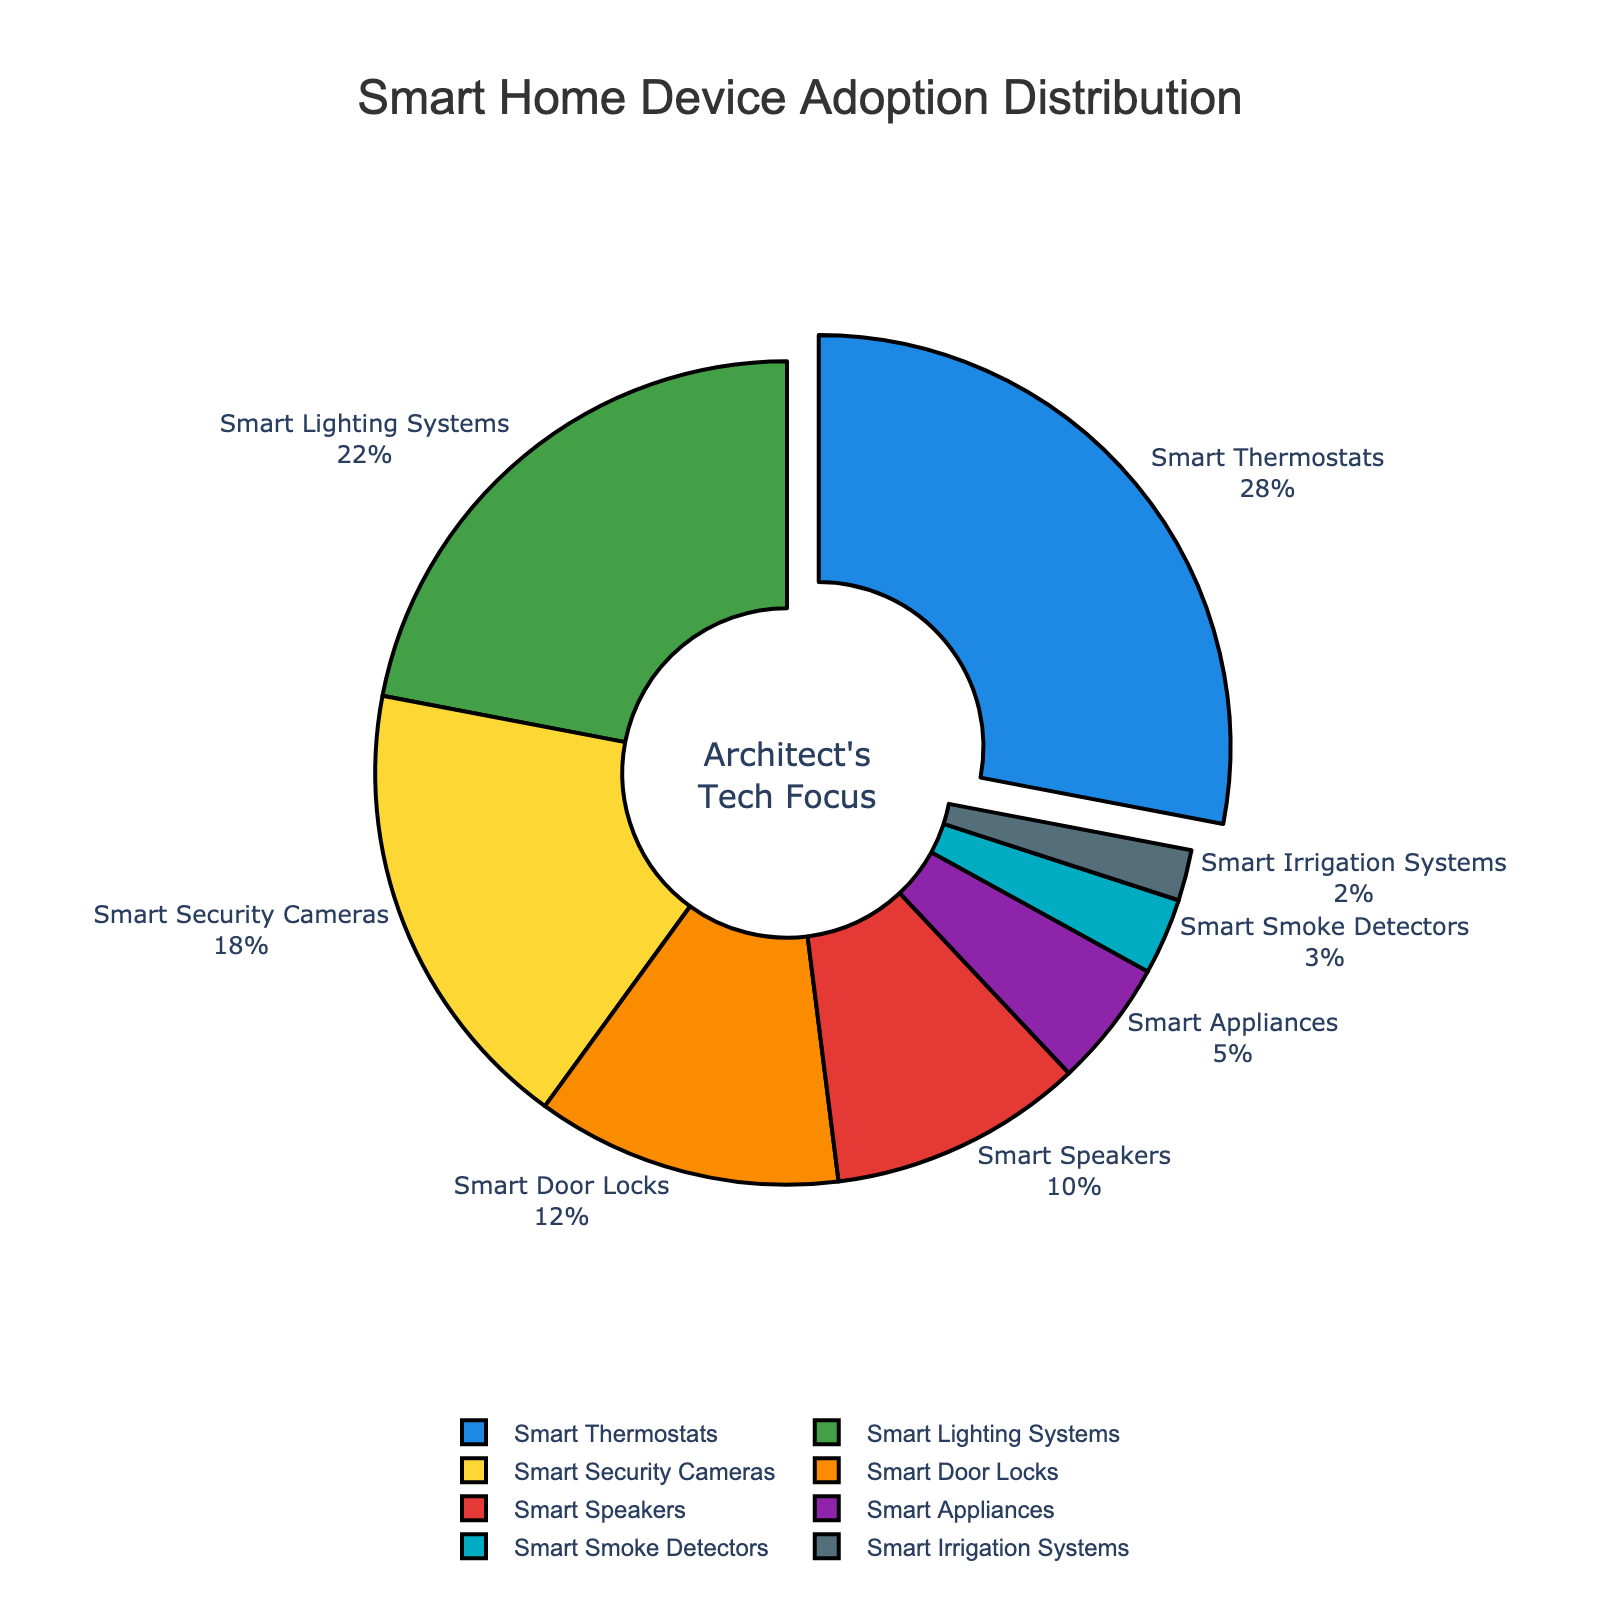Which smart home device type has the highest adoption percentage? The slice with the largest area in the pie chart represents the device type with the highest adoption percentage. In this case, it is the Smart Thermostats.
Answer: Smart Thermostats By how much is the adoption percentage of Smart Lighting Systems higher than that of Smart Speakers? The adoption percentage of Smart Lighting Systems is 22%, and that of Smart Speakers is 10%. The difference is 22% - 10% = 12%.
Answer: 12% What's the combined adoption percentage of Smart Security Cameras and Smart Door Locks? The adoption percentage of Smart Security Cameras is 18% and Smart Door Locks is 12%. The combined adoption is 18% + 12% = 30%.
Answer: 30% Which device types are adopted less than 10%? The slices that are smaller and fall under the 10% label are Smart Appliances, Smart Smoke Detectors, and Smart Irrigation Systems.
Answer: Smart Appliances, Smart Smoke Detectors, Smart Irrigation Systems What is the total adoption percentage for device types represented by the colors blue and green? The Smart Thermostats (blue) adoption is 28%, and Smart Lighting Systems (green) adoption is 22%. The total adoption is 28% + 22% = 50%.
Answer: 50% Which smart home device has the lowest adoption percentage, and what is that percentage? The smallest slice in the pie chart represents the device with the lowest adoption percentage, which is Smart Irrigation Systems with 2%.
Answer: Smart Irrigation Systems, 2% Is the adoption of Smart Thermostats more than twice the adoption of Smart Speakers? The adoption percentage of Smart Thermostats is 28%, and that of Smart Speakers is 10%. Doubling the adoption of Smart Speakers yields 10% * 2 = 20%, which is less than 28%.
Answer: Yes What is the average adoption percentage of Smart Appliances and Smart Smoke Detectors? The adoption percentages are 5% and 3% respectively. The average is (5% + 3%) / 2 = 8% / 2 = 4%.
Answer: 4% How does the adoption percentage of Smart Security Cameras compare to that of Smart Lighting Systems? The adoption percentage of Smart Security Cameras is 18%, which is 4% less than that of Smart Lighting Systems, which is 22%.
Answer: Smart Security Cameras are 4% less than Smart Lighting Systems What percentage of the market do the top three device types occupy? The top three device types are Smart Thermostats (28%), Smart Lighting Systems (22%), and Smart Security Cameras (18%). The combined percentage is 28% + 22% + 18% = 68%.
Answer: 68% 